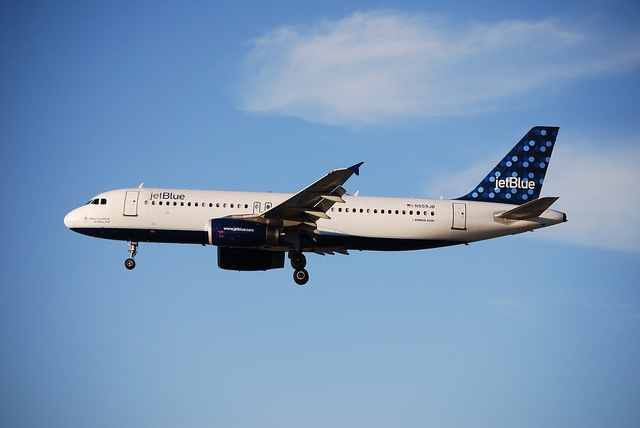Describe the objects in this image and their specific colors. I can see a airplane in darkblue, black, lightgray, and darkgray tones in this image. 